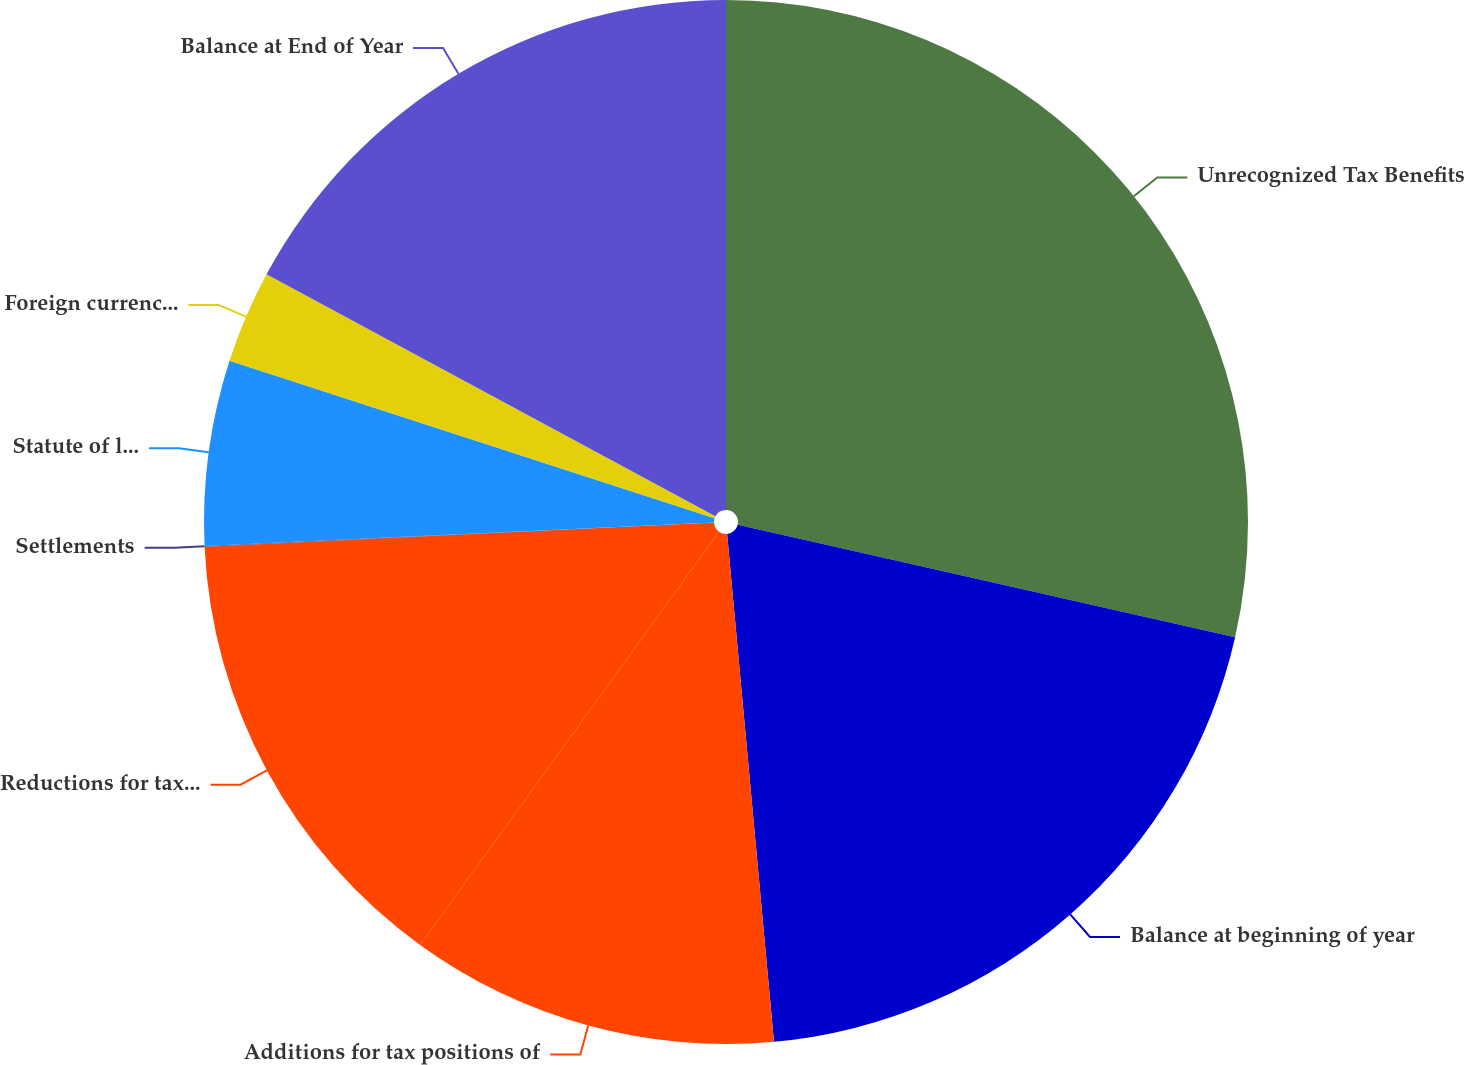<chart> <loc_0><loc_0><loc_500><loc_500><pie_chart><fcel>Unrecognized Tax Benefits<fcel>Balance at beginning of year<fcel>Additions for tax positions of<fcel>Reductions for tax positions<fcel>Settlements<fcel>Statute of limitations<fcel>Foreign currency translation<fcel>Balance at End of Year<nl><fcel>28.54%<fcel>19.99%<fcel>11.43%<fcel>14.28%<fcel>0.02%<fcel>5.73%<fcel>2.87%<fcel>17.13%<nl></chart> 